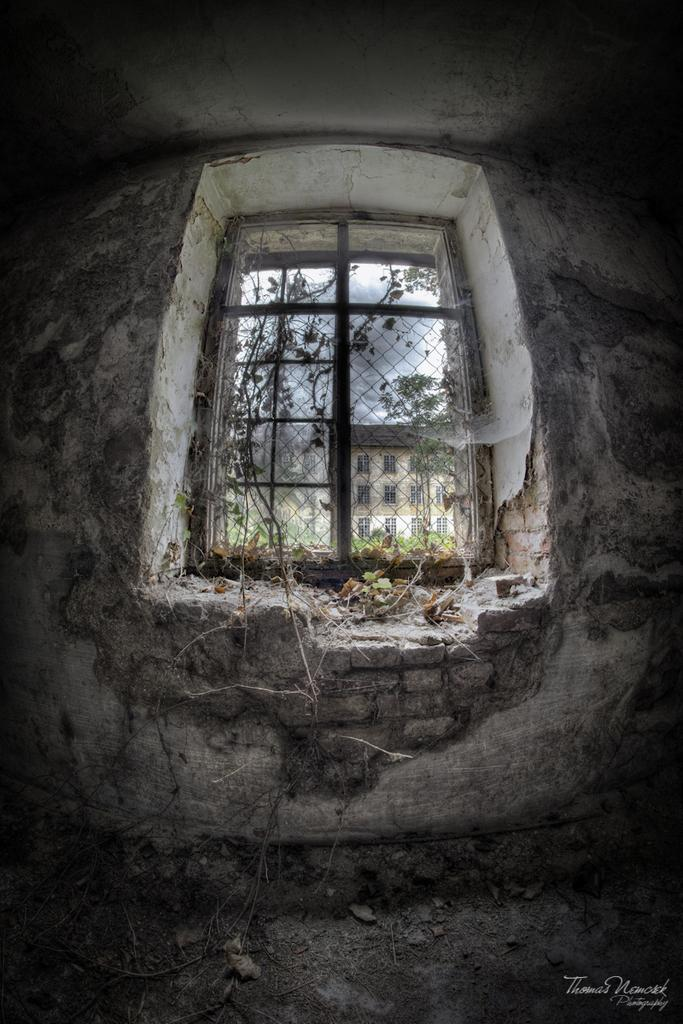What type of structure can be seen in the image? There is a building in the image. What is the purpose of the window in the image? The window allows light to enter the building and provides a view of the outside. What can be seen in the background of the image? There are trees and the sky visible in the image. What is the watermark in the bottom right corner of the image? The watermark is a mark or logo that indicates the ownership or source of the image. What time is displayed on the hour on the calendar in the image? There is no hour or calendar present in the image; it only features a building, window, trees, sky, and a watermark. 